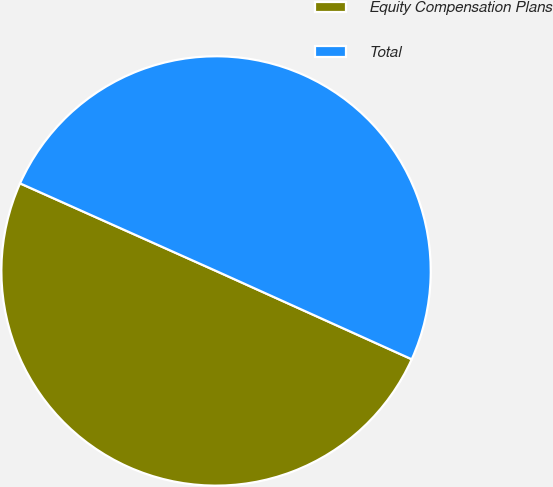<chart> <loc_0><loc_0><loc_500><loc_500><pie_chart><fcel>Equity Compensation Plans<fcel>Total<nl><fcel>49.94%<fcel>50.06%<nl></chart> 